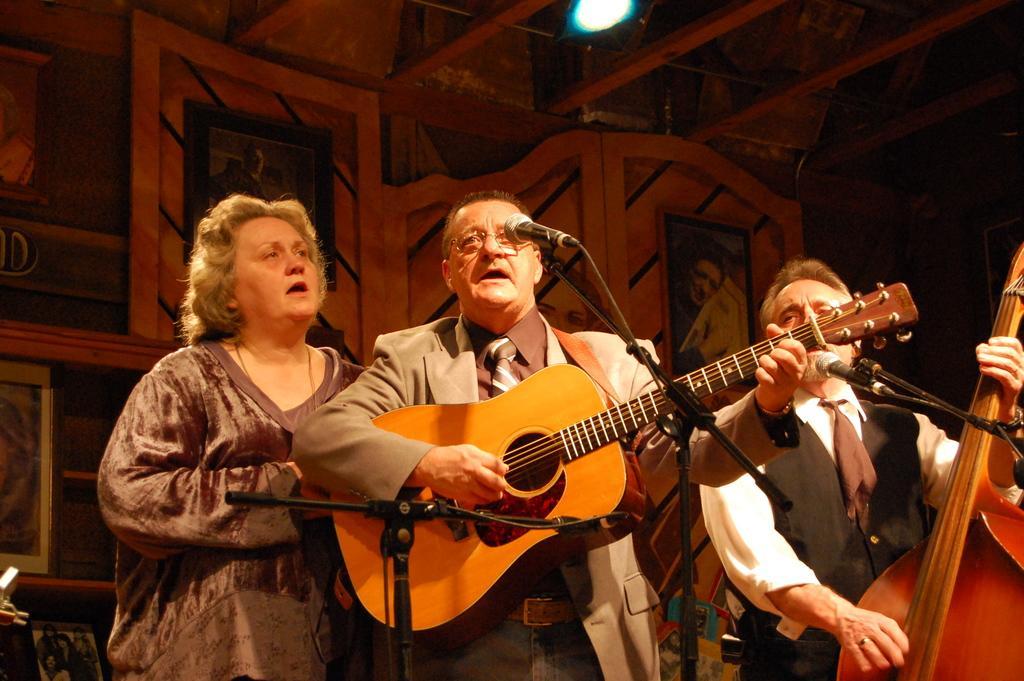In one or two sentences, can you explain what this image depicts? In this image I see 2 men who are holding a musical instrument and they are standing in front of a pic, I can also see there is a woman over here. In the background I see the light. 